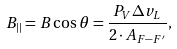<formula> <loc_0><loc_0><loc_500><loc_500>B _ { | | } = B \cos \theta = \frac { P _ { V } \Delta v _ { L } } { 2 \cdot A _ { F - F ^ { \prime } } } ,</formula> 